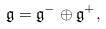Convert formula to latex. <formula><loc_0><loc_0><loc_500><loc_500>\mathfrak { g } = \mathfrak { g } ^ { - } \oplus \mathfrak { g } ^ { + } ,</formula> 